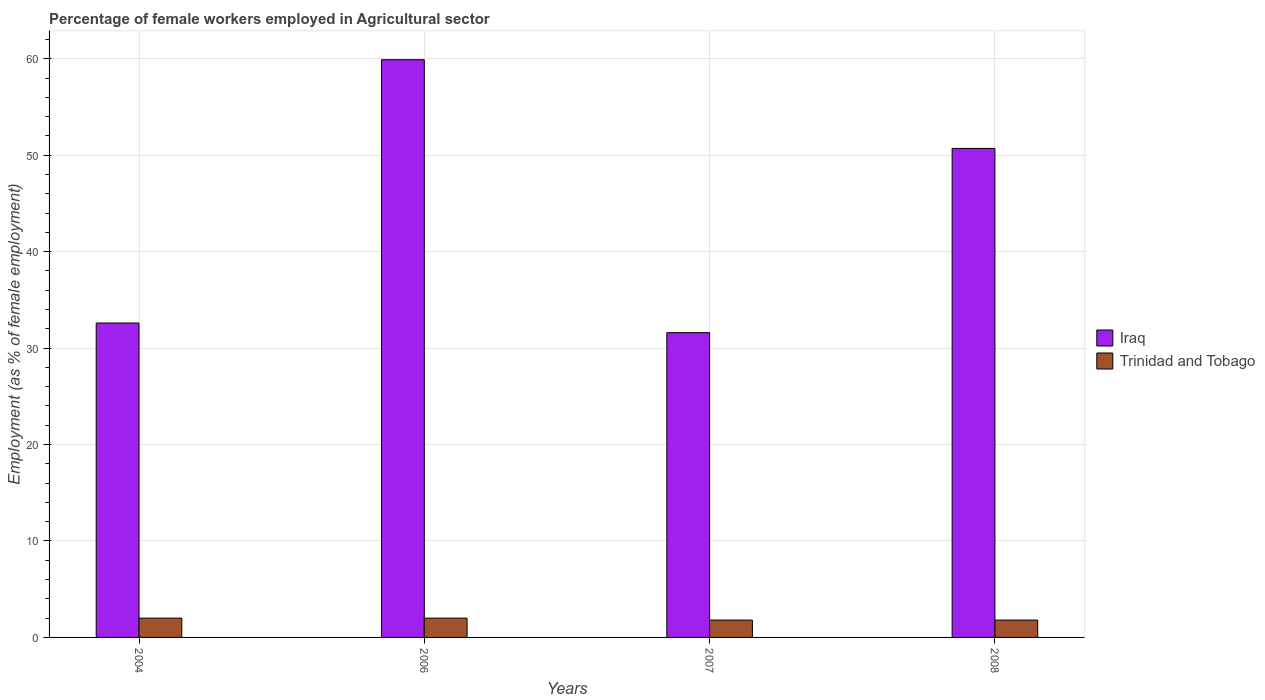Are the number of bars per tick equal to the number of legend labels?
Ensure brevity in your answer.  Yes. How many bars are there on the 1st tick from the left?
Keep it short and to the point. 2. How many bars are there on the 2nd tick from the right?
Offer a very short reply. 2. In how many cases, is the number of bars for a given year not equal to the number of legend labels?
Your response must be concise. 0. What is the percentage of females employed in Agricultural sector in Trinidad and Tobago in 2006?
Keep it short and to the point. 2. Across all years, what is the maximum percentage of females employed in Agricultural sector in Trinidad and Tobago?
Provide a succinct answer. 2. Across all years, what is the minimum percentage of females employed in Agricultural sector in Iraq?
Provide a short and direct response. 31.6. In which year was the percentage of females employed in Agricultural sector in Trinidad and Tobago maximum?
Offer a very short reply. 2004. What is the total percentage of females employed in Agricultural sector in Trinidad and Tobago in the graph?
Offer a terse response. 7.6. What is the difference between the percentage of females employed in Agricultural sector in Trinidad and Tobago in 2006 and that in 2007?
Your answer should be compact. 0.2. What is the difference between the percentage of females employed in Agricultural sector in Trinidad and Tobago in 2008 and the percentage of females employed in Agricultural sector in Iraq in 2006?
Keep it short and to the point. -58.1. What is the average percentage of females employed in Agricultural sector in Iraq per year?
Provide a short and direct response. 43.7. In the year 2006, what is the difference between the percentage of females employed in Agricultural sector in Iraq and percentage of females employed in Agricultural sector in Trinidad and Tobago?
Your answer should be compact. 57.9. In how many years, is the percentage of females employed in Agricultural sector in Iraq greater than 50 %?
Provide a succinct answer. 2. What is the ratio of the percentage of females employed in Agricultural sector in Trinidad and Tobago in 2004 to that in 2008?
Provide a short and direct response. 1.11. Is the difference between the percentage of females employed in Agricultural sector in Iraq in 2004 and 2006 greater than the difference between the percentage of females employed in Agricultural sector in Trinidad and Tobago in 2004 and 2006?
Ensure brevity in your answer.  No. What is the difference between the highest and the second highest percentage of females employed in Agricultural sector in Iraq?
Offer a very short reply. 9.2. What is the difference between the highest and the lowest percentage of females employed in Agricultural sector in Iraq?
Your answer should be very brief. 28.3. In how many years, is the percentage of females employed in Agricultural sector in Iraq greater than the average percentage of females employed in Agricultural sector in Iraq taken over all years?
Provide a succinct answer. 2. Is the sum of the percentage of females employed in Agricultural sector in Iraq in 2004 and 2008 greater than the maximum percentage of females employed in Agricultural sector in Trinidad and Tobago across all years?
Offer a very short reply. Yes. What does the 2nd bar from the left in 2006 represents?
Your answer should be very brief. Trinidad and Tobago. What does the 1st bar from the right in 2004 represents?
Ensure brevity in your answer.  Trinidad and Tobago. How many bars are there?
Your answer should be very brief. 8. What is the difference between two consecutive major ticks on the Y-axis?
Your answer should be very brief. 10. Does the graph contain grids?
Ensure brevity in your answer.  Yes. Where does the legend appear in the graph?
Provide a short and direct response. Center right. How many legend labels are there?
Keep it short and to the point. 2. What is the title of the graph?
Ensure brevity in your answer.  Percentage of female workers employed in Agricultural sector. What is the label or title of the X-axis?
Ensure brevity in your answer.  Years. What is the label or title of the Y-axis?
Keep it short and to the point. Employment (as % of female employment). What is the Employment (as % of female employment) of Iraq in 2004?
Make the answer very short. 32.6. What is the Employment (as % of female employment) in Trinidad and Tobago in 2004?
Offer a terse response. 2. What is the Employment (as % of female employment) of Iraq in 2006?
Your answer should be very brief. 59.9. What is the Employment (as % of female employment) in Iraq in 2007?
Give a very brief answer. 31.6. What is the Employment (as % of female employment) in Trinidad and Tobago in 2007?
Make the answer very short. 1.8. What is the Employment (as % of female employment) in Iraq in 2008?
Offer a terse response. 50.7. What is the Employment (as % of female employment) of Trinidad and Tobago in 2008?
Your answer should be compact. 1.8. Across all years, what is the maximum Employment (as % of female employment) of Iraq?
Offer a very short reply. 59.9. Across all years, what is the minimum Employment (as % of female employment) in Iraq?
Your response must be concise. 31.6. Across all years, what is the minimum Employment (as % of female employment) of Trinidad and Tobago?
Give a very brief answer. 1.8. What is the total Employment (as % of female employment) of Iraq in the graph?
Make the answer very short. 174.8. What is the difference between the Employment (as % of female employment) in Iraq in 2004 and that in 2006?
Provide a short and direct response. -27.3. What is the difference between the Employment (as % of female employment) in Iraq in 2004 and that in 2007?
Give a very brief answer. 1. What is the difference between the Employment (as % of female employment) in Iraq in 2004 and that in 2008?
Give a very brief answer. -18.1. What is the difference between the Employment (as % of female employment) in Trinidad and Tobago in 2004 and that in 2008?
Give a very brief answer. 0.2. What is the difference between the Employment (as % of female employment) of Iraq in 2006 and that in 2007?
Provide a succinct answer. 28.3. What is the difference between the Employment (as % of female employment) of Iraq in 2007 and that in 2008?
Ensure brevity in your answer.  -19.1. What is the difference between the Employment (as % of female employment) of Trinidad and Tobago in 2007 and that in 2008?
Offer a very short reply. 0. What is the difference between the Employment (as % of female employment) in Iraq in 2004 and the Employment (as % of female employment) in Trinidad and Tobago in 2006?
Offer a very short reply. 30.6. What is the difference between the Employment (as % of female employment) in Iraq in 2004 and the Employment (as % of female employment) in Trinidad and Tobago in 2007?
Ensure brevity in your answer.  30.8. What is the difference between the Employment (as % of female employment) of Iraq in 2004 and the Employment (as % of female employment) of Trinidad and Tobago in 2008?
Give a very brief answer. 30.8. What is the difference between the Employment (as % of female employment) in Iraq in 2006 and the Employment (as % of female employment) in Trinidad and Tobago in 2007?
Provide a succinct answer. 58.1. What is the difference between the Employment (as % of female employment) in Iraq in 2006 and the Employment (as % of female employment) in Trinidad and Tobago in 2008?
Provide a succinct answer. 58.1. What is the difference between the Employment (as % of female employment) of Iraq in 2007 and the Employment (as % of female employment) of Trinidad and Tobago in 2008?
Give a very brief answer. 29.8. What is the average Employment (as % of female employment) of Iraq per year?
Your response must be concise. 43.7. In the year 2004, what is the difference between the Employment (as % of female employment) in Iraq and Employment (as % of female employment) in Trinidad and Tobago?
Your response must be concise. 30.6. In the year 2006, what is the difference between the Employment (as % of female employment) of Iraq and Employment (as % of female employment) of Trinidad and Tobago?
Offer a very short reply. 57.9. In the year 2007, what is the difference between the Employment (as % of female employment) in Iraq and Employment (as % of female employment) in Trinidad and Tobago?
Your answer should be compact. 29.8. In the year 2008, what is the difference between the Employment (as % of female employment) in Iraq and Employment (as % of female employment) in Trinidad and Tobago?
Your answer should be compact. 48.9. What is the ratio of the Employment (as % of female employment) of Iraq in 2004 to that in 2006?
Your answer should be compact. 0.54. What is the ratio of the Employment (as % of female employment) of Trinidad and Tobago in 2004 to that in 2006?
Make the answer very short. 1. What is the ratio of the Employment (as % of female employment) of Iraq in 2004 to that in 2007?
Your response must be concise. 1.03. What is the ratio of the Employment (as % of female employment) of Iraq in 2004 to that in 2008?
Your response must be concise. 0.64. What is the ratio of the Employment (as % of female employment) of Iraq in 2006 to that in 2007?
Your answer should be very brief. 1.9. What is the ratio of the Employment (as % of female employment) of Trinidad and Tobago in 2006 to that in 2007?
Your answer should be compact. 1.11. What is the ratio of the Employment (as % of female employment) in Iraq in 2006 to that in 2008?
Provide a short and direct response. 1.18. What is the ratio of the Employment (as % of female employment) in Iraq in 2007 to that in 2008?
Your response must be concise. 0.62. What is the difference between the highest and the lowest Employment (as % of female employment) of Iraq?
Your response must be concise. 28.3. What is the difference between the highest and the lowest Employment (as % of female employment) in Trinidad and Tobago?
Your answer should be compact. 0.2. 